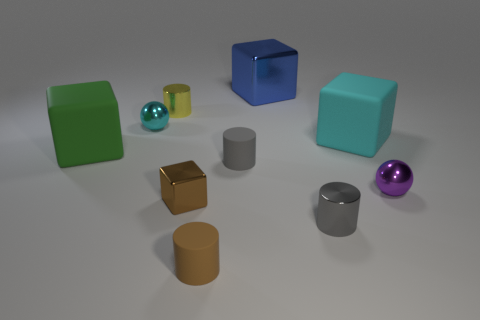Subtract all gray metallic cylinders. How many cylinders are left? 3 Subtract all green spheres. How many gray cylinders are left? 2 Subtract 2 blocks. How many blocks are left? 2 Subtract all brown cylinders. How many cylinders are left? 3 Subtract all cubes. How many objects are left? 6 Subtract all brown cylinders. Subtract all cyan balls. How many cylinders are left? 3 Subtract all tiny things. Subtract all tiny gray objects. How many objects are left? 1 Add 8 gray things. How many gray things are left? 10 Add 7 big matte cubes. How many big matte cubes exist? 9 Subtract 1 cyan cubes. How many objects are left? 9 